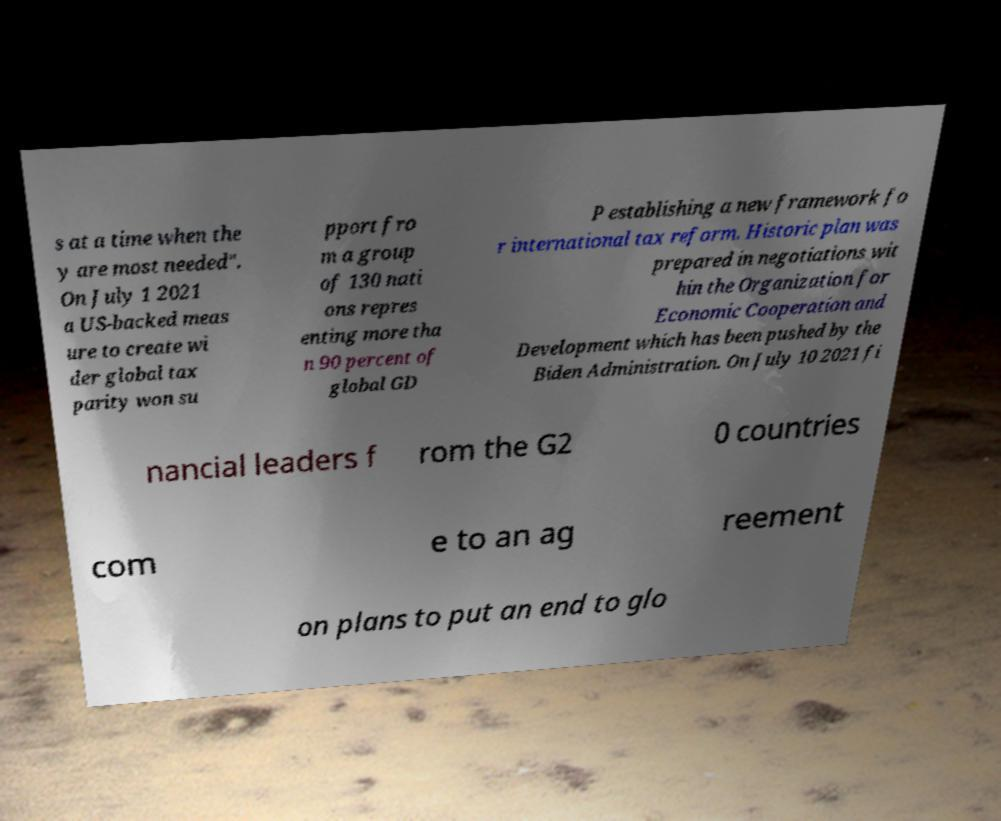Please read and relay the text visible in this image. What does it say? s at a time when the y are most needed". On July 1 2021 a US-backed meas ure to create wi der global tax parity won su pport fro m a group of 130 nati ons repres enting more tha n 90 percent of global GD P establishing a new framework fo r international tax reform. Historic plan was prepared in negotiations wit hin the Organization for Economic Cooperation and Development which has been pushed by the Biden Administration. On July 10 2021 fi nancial leaders f rom the G2 0 countries com e to an ag reement on plans to put an end to glo 